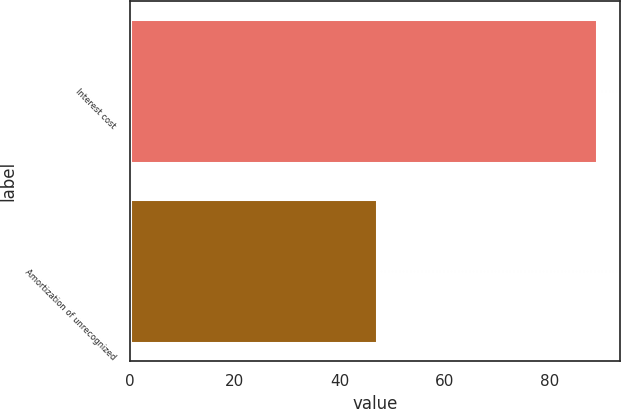Convert chart to OTSL. <chart><loc_0><loc_0><loc_500><loc_500><bar_chart><fcel>Interest cost<fcel>Amortization of unrecognized<nl><fcel>89<fcel>47<nl></chart> 